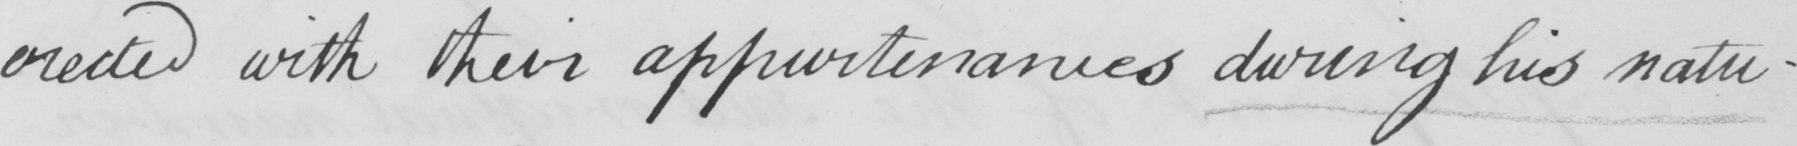Please transcribe the handwritten text in this image. erected with their appurtenances during his natu- 